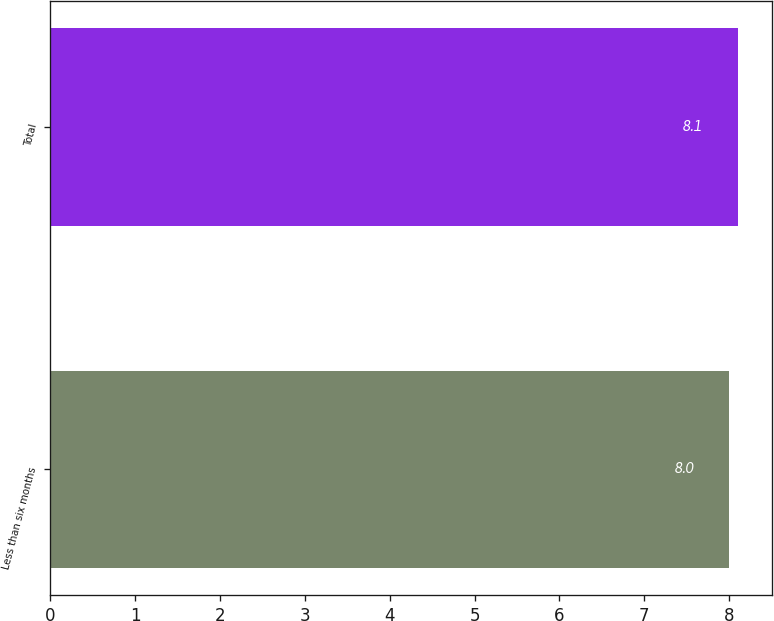Convert chart to OTSL. <chart><loc_0><loc_0><loc_500><loc_500><bar_chart><fcel>Less than six months<fcel>Total<nl><fcel>8<fcel>8.1<nl></chart> 